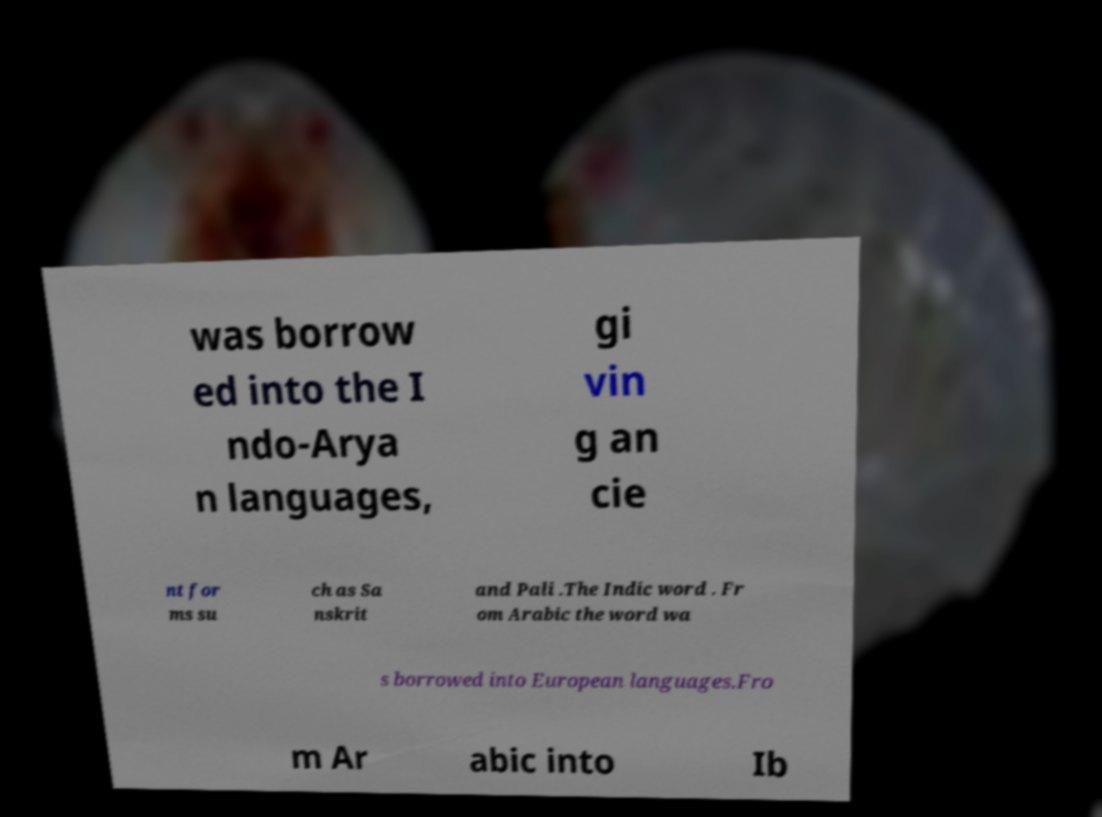Could you assist in decoding the text presented in this image and type it out clearly? was borrow ed into the I ndo-Arya n languages, gi vin g an cie nt for ms su ch as Sa nskrit and Pali .The Indic word . Fr om Arabic the word wa s borrowed into European languages.Fro m Ar abic into Ib 